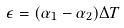<formula> <loc_0><loc_0><loc_500><loc_500>\epsilon = ( \alpha _ { 1 } - \alpha _ { 2 } ) \Delta T</formula> 